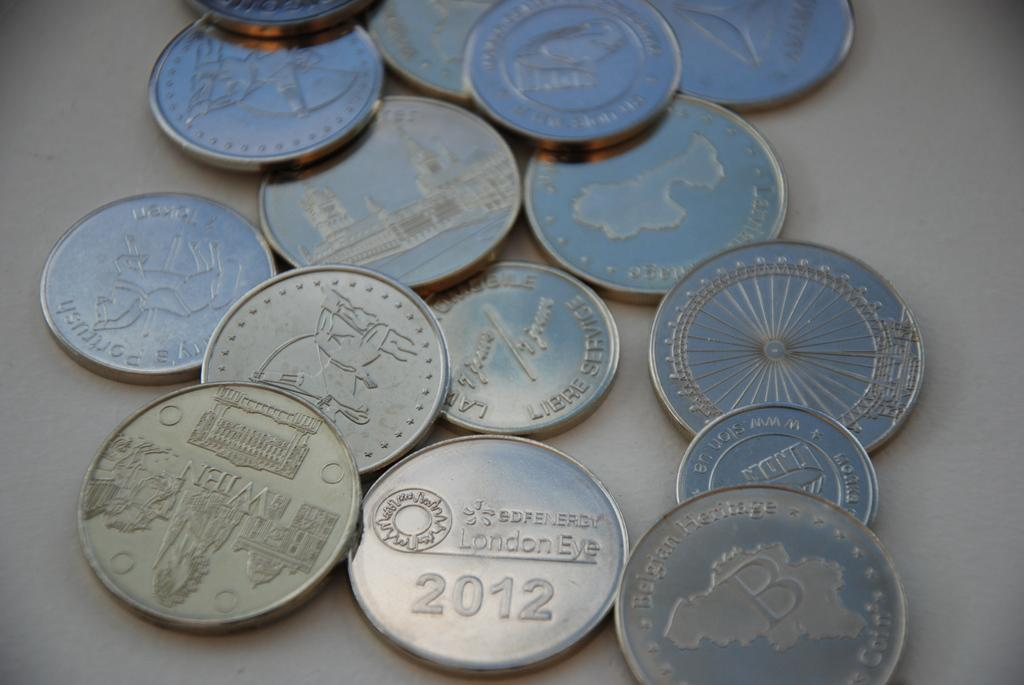<image>
Summarize the visual content of the image. A collection of silver coins and one is from 2012. 